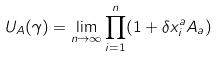<formula> <loc_0><loc_0><loc_500><loc_500>U _ { A } ( \gamma ) = \lim _ { n \rightarrow \infty } \prod _ { i = 1 } ^ { n } ( 1 + \delta x ^ { a } _ { i } { A } _ { a } )</formula> 